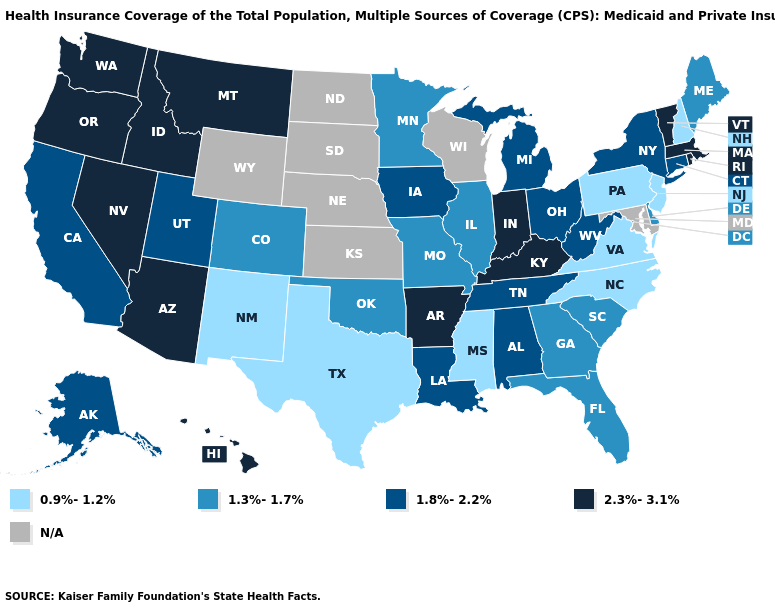What is the highest value in the USA?
Answer briefly. 2.3%-3.1%. What is the value of Kansas?
Be succinct. N/A. How many symbols are there in the legend?
Be succinct. 5. What is the value of Louisiana?
Give a very brief answer. 1.8%-2.2%. What is the value of Minnesota?
Answer briefly. 1.3%-1.7%. How many symbols are there in the legend?
Write a very short answer. 5. Which states have the lowest value in the USA?
Keep it brief. Mississippi, New Hampshire, New Jersey, New Mexico, North Carolina, Pennsylvania, Texas, Virginia. What is the value of Georgia?
Concise answer only. 1.3%-1.7%. What is the value of Illinois?
Answer briefly. 1.3%-1.7%. Name the states that have a value in the range 1.8%-2.2%?
Short answer required. Alabama, Alaska, California, Connecticut, Iowa, Louisiana, Michigan, New York, Ohio, Tennessee, Utah, West Virginia. What is the value of Hawaii?
Write a very short answer. 2.3%-3.1%. Does Illinois have the lowest value in the MidWest?
Short answer required. Yes. Among the states that border New York , which have the highest value?
Answer briefly. Massachusetts, Vermont. Among the states that border Iowa , which have the lowest value?
Answer briefly. Illinois, Minnesota, Missouri. What is the value of Minnesota?
Keep it brief. 1.3%-1.7%. 